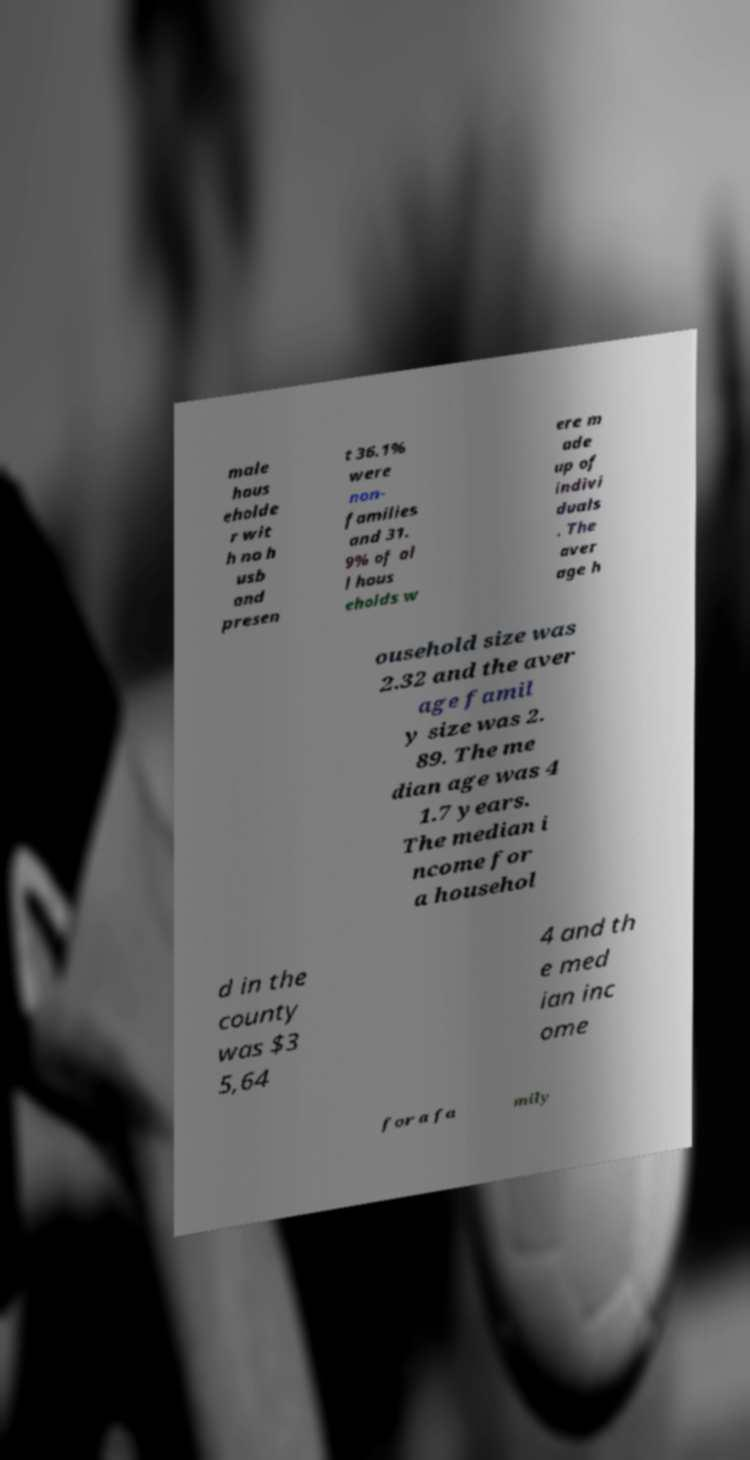Could you assist in decoding the text presented in this image and type it out clearly? male hous eholde r wit h no h usb and presen t 36.1% were non- families and 31. 9% of al l hous eholds w ere m ade up of indivi duals . The aver age h ousehold size was 2.32 and the aver age famil y size was 2. 89. The me dian age was 4 1.7 years. The median i ncome for a househol d in the county was $3 5,64 4 and th e med ian inc ome for a fa mily 